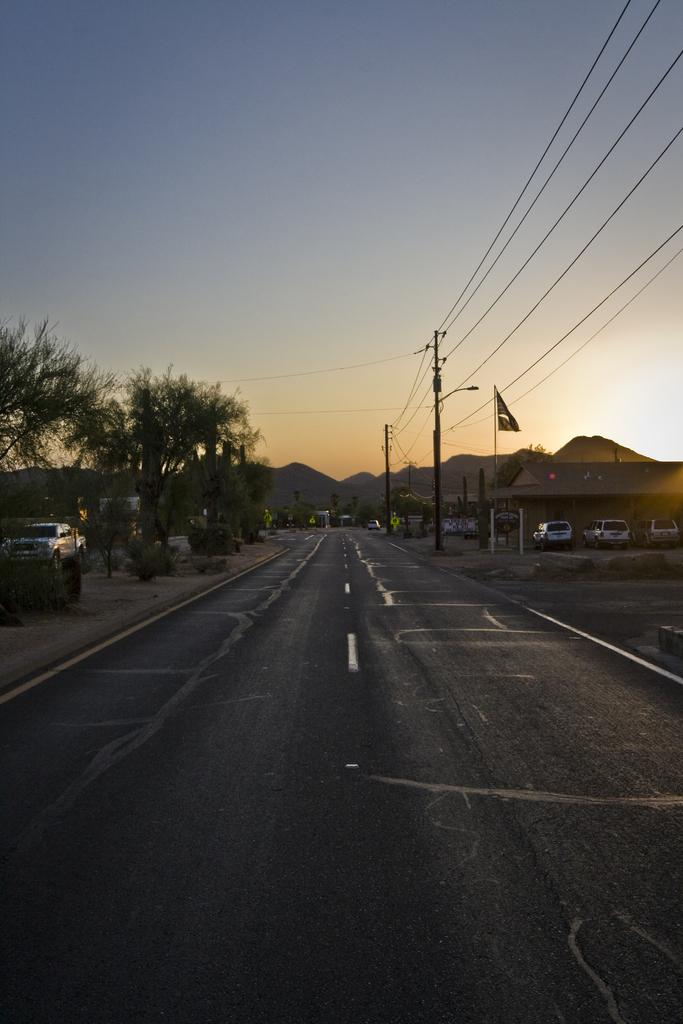What types of objects can be seen in the image? There are vehicles, transmission wires, poles, trees, and plants visible in the image. What is the purpose of the transmission wires in the image? The transmission wires are likely used for transmitting electricity or communication signals. What is the surface on which the vehicles are traveling? There is a road in the image, which is the surface on which the vehicles are traveling. What can be seen in the background of the image? The sky and hills are visible in the background of the image. What type of bell can be heard ringing in the image? There is no bell present in the image, and therefore no sound can be heard. What rhythm is being played by the plants in the image? The plants in the image are not playing any rhythm; they are stationary vegetation. 